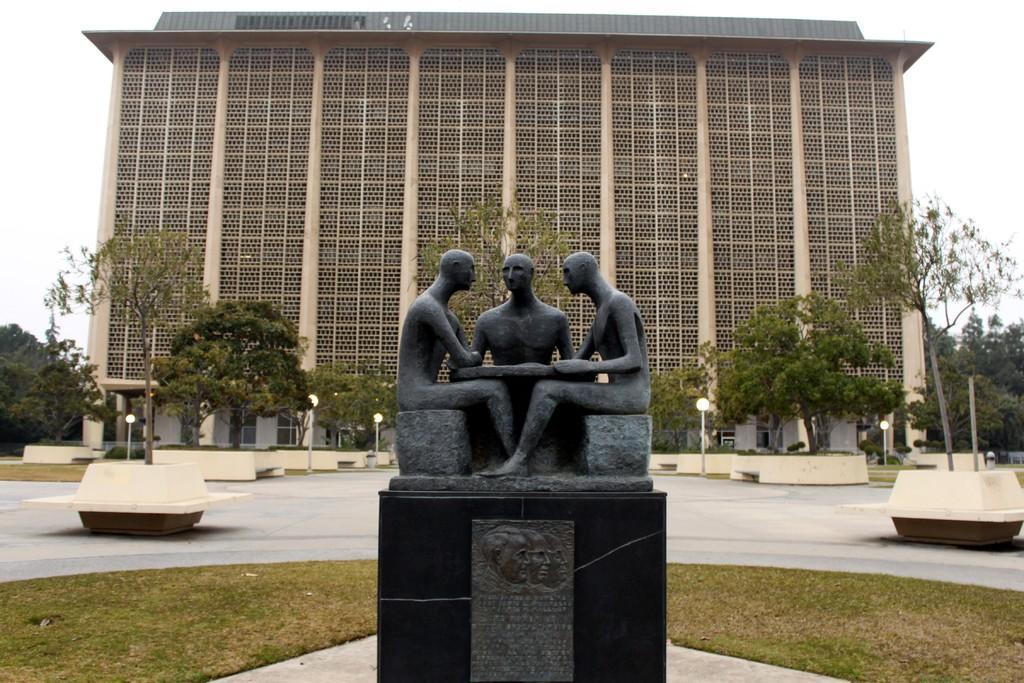Could you give a brief overview of what you see in this image? This image consists of a building. In the front, we can see the statues and a memorial stone. In the middle, there are lamps and trees. At the top, there is sky. At the bottom, there is green grass on the ground. 